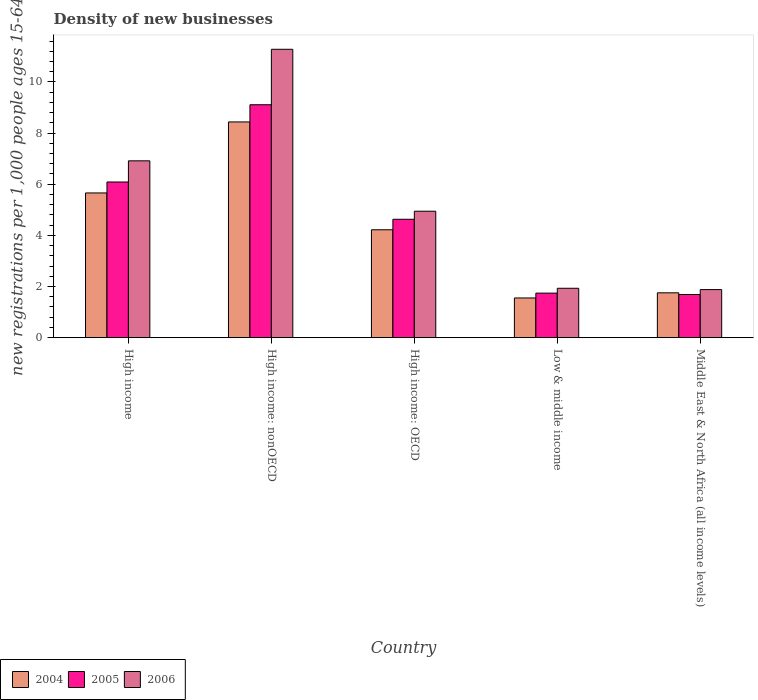Are the number of bars per tick equal to the number of legend labels?
Provide a short and direct response. Yes. How many bars are there on the 4th tick from the left?
Your answer should be very brief. 3. In how many cases, is the number of bars for a given country not equal to the number of legend labels?
Offer a very short reply. 0. What is the number of new registrations in 2004 in Low & middle income?
Offer a terse response. 1.55. Across all countries, what is the maximum number of new registrations in 2004?
Your answer should be compact. 8.44. Across all countries, what is the minimum number of new registrations in 2005?
Your answer should be compact. 1.69. In which country was the number of new registrations in 2004 maximum?
Keep it short and to the point. High income: nonOECD. In which country was the number of new registrations in 2006 minimum?
Keep it short and to the point. Middle East & North Africa (all income levels). What is the total number of new registrations in 2006 in the graph?
Offer a terse response. 26.95. What is the difference between the number of new registrations in 2004 in High income and that in High income: nonOECD?
Provide a short and direct response. -2.78. What is the difference between the number of new registrations in 2005 in High income and the number of new registrations in 2006 in Middle East & North Africa (all income levels)?
Your response must be concise. 4.21. What is the average number of new registrations in 2006 per country?
Your answer should be very brief. 5.39. What is the difference between the number of new registrations of/in 2006 and number of new registrations of/in 2005 in Middle East & North Africa (all income levels)?
Your answer should be compact. 0.19. In how many countries, is the number of new registrations in 2006 greater than 1.2000000000000002?
Give a very brief answer. 5. What is the ratio of the number of new registrations in 2004 in Low & middle income to that in Middle East & North Africa (all income levels)?
Your answer should be very brief. 0.89. Is the difference between the number of new registrations in 2006 in High income: OECD and High income: nonOECD greater than the difference between the number of new registrations in 2005 in High income: OECD and High income: nonOECD?
Your answer should be very brief. No. What is the difference between the highest and the second highest number of new registrations in 2005?
Your response must be concise. 4.48. What is the difference between the highest and the lowest number of new registrations in 2005?
Your answer should be compact. 7.42. In how many countries, is the number of new registrations in 2006 greater than the average number of new registrations in 2006 taken over all countries?
Ensure brevity in your answer.  2. Is the sum of the number of new registrations in 2006 in High income: OECD and Middle East & North Africa (all income levels) greater than the maximum number of new registrations in 2005 across all countries?
Provide a short and direct response. No. What does the 3rd bar from the left in High income represents?
Provide a short and direct response. 2006. What does the 2nd bar from the right in High income represents?
Your answer should be compact. 2005. Is it the case that in every country, the sum of the number of new registrations in 2006 and number of new registrations in 2004 is greater than the number of new registrations in 2005?
Give a very brief answer. Yes. How many bars are there?
Keep it short and to the point. 15. Are all the bars in the graph horizontal?
Offer a very short reply. No. How many countries are there in the graph?
Provide a short and direct response. 5. What is the difference between two consecutive major ticks on the Y-axis?
Your answer should be very brief. 2. Are the values on the major ticks of Y-axis written in scientific E-notation?
Give a very brief answer. No. Does the graph contain grids?
Provide a succinct answer. No. Where does the legend appear in the graph?
Your answer should be compact. Bottom left. What is the title of the graph?
Ensure brevity in your answer.  Density of new businesses. Does "1966" appear as one of the legend labels in the graph?
Your answer should be very brief. No. What is the label or title of the Y-axis?
Keep it short and to the point. New registrations per 1,0 people ages 15-64. What is the new registrations per 1,000 people ages 15-64 of 2004 in High income?
Ensure brevity in your answer.  5.66. What is the new registrations per 1,000 people ages 15-64 in 2005 in High income?
Ensure brevity in your answer.  6.09. What is the new registrations per 1,000 people ages 15-64 in 2006 in High income?
Provide a short and direct response. 6.91. What is the new registrations per 1,000 people ages 15-64 in 2004 in High income: nonOECD?
Your response must be concise. 8.44. What is the new registrations per 1,000 people ages 15-64 in 2005 in High income: nonOECD?
Ensure brevity in your answer.  9.11. What is the new registrations per 1,000 people ages 15-64 in 2006 in High income: nonOECD?
Your response must be concise. 11.28. What is the new registrations per 1,000 people ages 15-64 of 2004 in High income: OECD?
Offer a very short reply. 4.22. What is the new registrations per 1,000 people ages 15-64 in 2005 in High income: OECD?
Provide a short and direct response. 4.63. What is the new registrations per 1,000 people ages 15-64 in 2006 in High income: OECD?
Your response must be concise. 4.94. What is the new registrations per 1,000 people ages 15-64 of 2004 in Low & middle income?
Give a very brief answer. 1.55. What is the new registrations per 1,000 people ages 15-64 of 2005 in Low & middle income?
Give a very brief answer. 1.74. What is the new registrations per 1,000 people ages 15-64 in 2006 in Low & middle income?
Give a very brief answer. 1.93. What is the new registrations per 1,000 people ages 15-64 of 2004 in Middle East & North Africa (all income levels)?
Make the answer very short. 1.75. What is the new registrations per 1,000 people ages 15-64 in 2005 in Middle East & North Africa (all income levels)?
Offer a terse response. 1.69. What is the new registrations per 1,000 people ages 15-64 in 2006 in Middle East & North Africa (all income levels)?
Give a very brief answer. 1.88. Across all countries, what is the maximum new registrations per 1,000 people ages 15-64 in 2004?
Make the answer very short. 8.44. Across all countries, what is the maximum new registrations per 1,000 people ages 15-64 in 2005?
Your answer should be very brief. 9.11. Across all countries, what is the maximum new registrations per 1,000 people ages 15-64 in 2006?
Provide a short and direct response. 11.28. Across all countries, what is the minimum new registrations per 1,000 people ages 15-64 of 2004?
Your answer should be compact. 1.55. Across all countries, what is the minimum new registrations per 1,000 people ages 15-64 in 2005?
Your answer should be very brief. 1.69. Across all countries, what is the minimum new registrations per 1,000 people ages 15-64 in 2006?
Keep it short and to the point. 1.88. What is the total new registrations per 1,000 people ages 15-64 in 2004 in the graph?
Give a very brief answer. 21.62. What is the total new registrations per 1,000 people ages 15-64 in 2005 in the graph?
Provide a succinct answer. 23.25. What is the total new registrations per 1,000 people ages 15-64 in 2006 in the graph?
Ensure brevity in your answer.  26.95. What is the difference between the new registrations per 1,000 people ages 15-64 of 2004 in High income and that in High income: nonOECD?
Give a very brief answer. -2.78. What is the difference between the new registrations per 1,000 people ages 15-64 of 2005 in High income and that in High income: nonOECD?
Provide a short and direct response. -3.02. What is the difference between the new registrations per 1,000 people ages 15-64 in 2006 in High income and that in High income: nonOECD?
Ensure brevity in your answer.  -4.36. What is the difference between the new registrations per 1,000 people ages 15-64 of 2004 in High income and that in High income: OECD?
Ensure brevity in your answer.  1.44. What is the difference between the new registrations per 1,000 people ages 15-64 of 2005 in High income and that in High income: OECD?
Your answer should be compact. 1.46. What is the difference between the new registrations per 1,000 people ages 15-64 of 2006 in High income and that in High income: OECD?
Keep it short and to the point. 1.97. What is the difference between the new registrations per 1,000 people ages 15-64 of 2004 in High income and that in Low & middle income?
Your answer should be very brief. 4.11. What is the difference between the new registrations per 1,000 people ages 15-64 of 2005 in High income and that in Low & middle income?
Your answer should be compact. 4.35. What is the difference between the new registrations per 1,000 people ages 15-64 in 2006 in High income and that in Low & middle income?
Offer a very short reply. 4.98. What is the difference between the new registrations per 1,000 people ages 15-64 in 2004 in High income and that in Middle East & North Africa (all income levels)?
Offer a very short reply. 3.91. What is the difference between the new registrations per 1,000 people ages 15-64 in 2005 in High income and that in Middle East & North Africa (all income levels)?
Ensure brevity in your answer.  4.4. What is the difference between the new registrations per 1,000 people ages 15-64 in 2006 in High income and that in Middle East & North Africa (all income levels)?
Provide a succinct answer. 5.04. What is the difference between the new registrations per 1,000 people ages 15-64 in 2004 in High income: nonOECD and that in High income: OECD?
Ensure brevity in your answer.  4.22. What is the difference between the new registrations per 1,000 people ages 15-64 in 2005 in High income: nonOECD and that in High income: OECD?
Your answer should be very brief. 4.48. What is the difference between the new registrations per 1,000 people ages 15-64 in 2006 in High income: nonOECD and that in High income: OECD?
Ensure brevity in your answer.  6.33. What is the difference between the new registrations per 1,000 people ages 15-64 in 2004 in High income: nonOECD and that in Low & middle income?
Your response must be concise. 6.88. What is the difference between the new registrations per 1,000 people ages 15-64 of 2005 in High income: nonOECD and that in Low & middle income?
Offer a terse response. 7.37. What is the difference between the new registrations per 1,000 people ages 15-64 in 2006 in High income: nonOECD and that in Low & middle income?
Give a very brief answer. 9.34. What is the difference between the new registrations per 1,000 people ages 15-64 of 2004 in High income: nonOECD and that in Middle East & North Africa (all income levels)?
Your answer should be compact. 6.68. What is the difference between the new registrations per 1,000 people ages 15-64 of 2005 in High income: nonOECD and that in Middle East & North Africa (all income levels)?
Your response must be concise. 7.42. What is the difference between the new registrations per 1,000 people ages 15-64 of 2006 in High income: nonOECD and that in Middle East & North Africa (all income levels)?
Offer a very short reply. 9.4. What is the difference between the new registrations per 1,000 people ages 15-64 in 2004 in High income: OECD and that in Low & middle income?
Offer a very short reply. 2.67. What is the difference between the new registrations per 1,000 people ages 15-64 of 2005 in High income: OECD and that in Low & middle income?
Provide a short and direct response. 2.89. What is the difference between the new registrations per 1,000 people ages 15-64 in 2006 in High income: OECD and that in Low & middle income?
Ensure brevity in your answer.  3.01. What is the difference between the new registrations per 1,000 people ages 15-64 in 2004 in High income: OECD and that in Middle East & North Africa (all income levels)?
Your response must be concise. 2.47. What is the difference between the new registrations per 1,000 people ages 15-64 of 2005 in High income: OECD and that in Middle East & North Africa (all income levels)?
Make the answer very short. 2.94. What is the difference between the new registrations per 1,000 people ages 15-64 of 2006 in High income: OECD and that in Middle East & North Africa (all income levels)?
Make the answer very short. 3.07. What is the difference between the new registrations per 1,000 people ages 15-64 of 2004 in Low & middle income and that in Middle East & North Africa (all income levels)?
Keep it short and to the point. -0.2. What is the difference between the new registrations per 1,000 people ages 15-64 of 2005 in Low & middle income and that in Middle East & North Africa (all income levels)?
Give a very brief answer. 0.05. What is the difference between the new registrations per 1,000 people ages 15-64 in 2006 in Low & middle income and that in Middle East & North Africa (all income levels)?
Your answer should be very brief. 0.05. What is the difference between the new registrations per 1,000 people ages 15-64 of 2004 in High income and the new registrations per 1,000 people ages 15-64 of 2005 in High income: nonOECD?
Ensure brevity in your answer.  -3.45. What is the difference between the new registrations per 1,000 people ages 15-64 in 2004 in High income and the new registrations per 1,000 people ages 15-64 in 2006 in High income: nonOECD?
Make the answer very short. -5.62. What is the difference between the new registrations per 1,000 people ages 15-64 in 2005 in High income and the new registrations per 1,000 people ages 15-64 in 2006 in High income: nonOECD?
Your answer should be compact. -5.19. What is the difference between the new registrations per 1,000 people ages 15-64 of 2004 in High income and the new registrations per 1,000 people ages 15-64 of 2005 in High income: OECD?
Your response must be concise. 1.03. What is the difference between the new registrations per 1,000 people ages 15-64 in 2004 in High income and the new registrations per 1,000 people ages 15-64 in 2006 in High income: OECD?
Keep it short and to the point. 0.71. What is the difference between the new registrations per 1,000 people ages 15-64 in 2005 in High income and the new registrations per 1,000 people ages 15-64 in 2006 in High income: OECD?
Give a very brief answer. 1.14. What is the difference between the new registrations per 1,000 people ages 15-64 in 2004 in High income and the new registrations per 1,000 people ages 15-64 in 2005 in Low & middle income?
Provide a succinct answer. 3.92. What is the difference between the new registrations per 1,000 people ages 15-64 in 2004 in High income and the new registrations per 1,000 people ages 15-64 in 2006 in Low & middle income?
Your answer should be compact. 3.73. What is the difference between the new registrations per 1,000 people ages 15-64 in 2005 in High income and the new registrations per 1,000 people ages 15-64 in 2006 in Low & middle income?
Your answer should be very brief. 4.16. What is the difference between the new registrations per 1,000 people ages 15-64 in 2004 in High income and the new registrations per 1,000 people ages 15-64 in 2005 in Middle East & North Africa (all income levels)?
Your answer should be very brief. 3.97. What is the difference between the new registrations per 1,000 people ages 15-64 of 2004 in High income and the new registrations per 1,000 people ages 15-64 of 2006 in Middle East & North Africa (all income levels)?
Ensure brevity in your answer.  3.78. What is the difference between the new registrations per 1,000 people ages 15-64 in 2005 in High income and the new registrations per 1,000 people ages 15-64 in 2006 in Middle East & North Africa (all income levels)?
Offer a terse response. 4.21. What is the difference between the new registrations per 1,000 people ages 15-64 in 2004 in High income: nonOECD and the new registrations per 1,000 people ages 15-64 in 2005 in High income: OECD?
Your response must be concise. 3.81. What is the difference between the new registrations per 1,000 people ages 15-64 in 2004 in High income: nonOECD and the new registrations per 1,000 people ages 15-64 in 2006 in High income: OECD?
Your answer should be compact. 3.49. What is the difference between the new registrations per 1,000 people ages 15-64 in 2005 in High income: nonOECD and the new registrations per 1,000 people ages 15-64 in 2006 in High income: OECD?
Offer a terse response. 4.16. What is the difference between the new registrations per 1,000 people ages 15-64 in 2004 in High income: nonOECD and the new registrations per 1,000 people ages 15-64 in 2005 in Low & middle income?
Ensure brevity in your answer.  6.69. What is the difference between the new registrations per 1,000 people ages 15-64 of 2004 in High income: nonOECD and the new registrations per 1,000 people ages 15-64 of 2006 in Low & middle income?
Ensure brevity in your answer.  6.5. What is the difference between the new registrations per 1,000 people ages 15-64 of 2005 in High income: nonOECD and the new registrations per 1,000 people ages 15-64 of 2006 in Low & middle income?
Ensure brevity in your answer.  7.18. What is the difference between the new registrations per 1,000 people ages 15-64 in 2004 in High income: nonOECD and the new registrations per 1,000 people ages 15-64 in 2005 in Middle East & North Africa (all income levels)?
Offer a very short reply. 6.75. What is the difference between the new registrations per 1,000 people ages 15-64 in 2004 in High income: nonOECD and the new registrations per 1,000 people ages 15-64 in 2006 in Middle East & North Africa (all income levels)?
Give a very brief answer. 6.56. What is the difference between the new registrations per 1,000 people ages 15-64 of 2005 in High income: nonOECD and the new registrations per 1,000 people ages 15-64 of 2006 in Middle East & North Africa (all income levels)?
Your answer should be very brief. 7.23. What is the difference between the new registrations per 1,000 people ages 15-64 of 2004 in High income: OECD and the new registrations per 1,000 people ages 15-64 of 2005 in Low & middle income?
Offer a terse response. 2.48. What is the difference between the new registrations per 1,000 people ages 15-64 in 2004 in High income: OECD and the new registrations per 1,000 people ages 15-64 in 2006 in Low & middle income?
Keep it short and to the point. 2.29. What is the difference between the new registrations per 1,000 people ages 15-64 in 2005 in High income: OECD and the new registrations per 1,000 people ages 15-64 in 2006 in Low & middle income?
Offer a very short reply. 2.7. What is the difference between the new registrations per 1,000 people ages 15-64 of 2004 in High income: OECD and the new registrations per 1,000 people ages 15-64 of 2005 in Middle East & North Africa (all income levels)?
Make the answer very short. 2.53. What is the difference between the new registrations per 1,000 people ages 15-64 in 2004 in High income: OECD and the new registrations per 1,000 people ages 15-64 in 2006 in Middle East & North Africa (all income levels)?
Provide a short and direct response. 2.34. What is the difference between the new registrations per 1,000 people ages 15-64 of 2005 in High income: OECD and the new registrations per 1,000 people ages 15-64 of 2006 in Middle East & North Africa (all income levels)?
Ensure brevity in your answer.  2.75. What is the difference between the new registrations per 1,000 people ages 15-64 in 2004 in Low & middle income and the new registrations per 1,000 people ages 15-64 in 2005 in Middle East & North Africa (all income levels)?
Make the answer very short. -0.13. What is the difference between the new registrations per 1,000 people ages 15-64 in 2004 in Low & middle income and the new registrations per 1,000 people ages 15-64 in 2006 in Middle East & North Africa (all income levels)?
Your answer should be very brief. -0.33. What is the difference between the new registrations per 1,000 people ages 15-64 of 2005 in Low & middle income and the new registrations per 1,000 people ages 15-64 of 2006 in Middle East & North Africa (all income levels)?
Provide a short and direct response. -0.14. What is the average new registrations per 1,000 people ages 15-64 in 2004 per country?
Provide a short and direct response. 4.32. What is the average new registrations per 1,000 people ages 15-64 in 2005 per country?
Your answer should be compact. 4.65. What is the average new registrations per 1,000 people ages 15-64 in 2006 per country?
Keep it short and to the point. 5.39. What is the difference between the new registrations per 1,000 people ages 15-64 in 2004 and new registrations per 1,000 people ages 15-64 in 2005 in High income?
Make the answer very short. -0.43. What is the difference between the new registrations per 1,000 people ages 15-64 in 2004 and new registrations per 1,000 people ages 15-64 in 2006 in High income?
Ensure brevity in your answer.  -1.26. What is the difference between the new registrations per 1,000 people ages 15-64 of 2005 and new registrations per 1,000 people ages 15-64 of 2006 in High income?
Provide a succinct answer. -0.83. What is the difference between the new registrations per 1,000 people ages 15-64 of 2004 and new registrations per 1,000 people ages 15-64 of 2005 in High income: nonOECD?
Your response must be concise. -0.67. What is the difference between the new registrations per 1,000 people ages 15-64 in 2004 and new registrations per 1,000 people ages 15-64 in 2006 in High income: nonOECD?
Keep it short and to the point. -2.84. What is the difference between the new registrations per 1,000 people ages 15-64 of 2005 and new registrations per 1,000 people ages 15-64 of 2006 in High income: nonOECD?
Your answer should be compact. -2.17. What is the difference between the new registrations per 1,000 people ages 15-64 of 2004 and new registrations per 1,000 people ages 15-64 of 2005 in High income: OECD?
Offer a very short reply. -0.41. What is the difference between the new registrations per 1,000 people ages 15-64 in 2004 and new registrations per 1,000 people ages 15-64 in 2006 in High income: OECD?
Offer a very short reply. -0.73. What is the difference between the new registrations per 1,000 people ages 15-64 of 2005 and new registrations per 1,000 people ages 15-64 of 2006 in High income: OECD?
Give a very brief answer. -0.32. What is the difference between the new registrations per 1,000 people ages 15-64 in 2004 and new registrations per 1,000 people ages 15-64 in 2005 in Low & middle income?
Make the answer very short. -0.19. What is the difference between the new registrations per 1,000 people ages 15-64 in 2004 and new registrations per 1,000 people ages 15-64 in 2006 in Low & middle income?
Give a very brief answer. -0.38. What is the difference between the new registrations per 1,000 people ages 15-64 of 2005 and new registrations per 1,000 people ages 15-64 of 2006 in Low & middle income?
Ensure brevity in your answer.  -0.19. What is the difference between the new registrations per 1,000 people ages 15-64 of 2004 and new registrations per 1,000 people ages 15-64 of 2005 in Middle East & North Africa (all income levels)?
Give a very brief answer. 0.07. What is the difference between the new registrations per 1,000 people ages 15-64 of 2004 and new registrations per 1,000 people ages 15-64 of 2006 in Middle East & North Africa (all income levels)?
Ensure brevity in your answer.  -0.13. What is the difference between the new registrations per 1,000 people ages 15-64 in 2005 and new registrations per 1,000 people ages 15-64 in 2006 in Middle East & North Africa (all income levels)?
Keep it short and to the point. -0.19. What is the ratio of the new registrations per 1,000 people ages 15-64 of 2004 in High income to that in High income: nonOECD?
Your answer should be very brief. 0.67. What is the ratio of the new registrations per 1,000 people ages 15-64 of 2005 in High income to that in High income: nonOECD?
Make the answer very short. 0.67. What is the ratio of the new registrations per 1,000 people ages 15-64 in 2006 in High income to that in High income: nonOECD?
Offer a terse response. 0.61. What is the ratio of the new registrations per 1,000 people ages 15-64 in 2004 in High income to that in High income: OECD?
Keep it short and to the point. 1.34. What is the ratio of the new registrations per 1,000 people ages 15-64 in 2005 in High income to that in High income: OECD?
Keep it short and to the point. 1.31. What is the ratio of the new registrations per 1,000 people ages 15-64 of 2006 in High income to that in High income: OECD?
Your answer should be compact. 1.4. What is the ratio of the new registrations per 1,000 people ages 15-64 of 2004 in High income to that in Low & middle income?
Offer a very short reply. 3.64. What is the ratio of the new registrations per 1,000 people ages 15-64 in 2005 in High income to that in Low & middle income?
Provide a succinct answer. 3.5. What is the ratio of the new registrations per 1,000 people ages 15-64 of 2006 in High income to that in Low & middle income?
Your answer should be compact. 3.58. What is the ratio of the new registrations per 1,000 people ages 15-64 in 2004 in High income to that in Middle East & North Africa (all income levels)?
Offer a terse response. 3.23. What is the ratio of the new registrations per 1,000 people ages 15-64 of 2005 in High income to that in Middle East & North Africa (all income levels)?
Your response must be concise. 3.61. What is the ratio of the new registrations per 1,000 people ages 15-64 in 2006 in High income to that in Middle East & North Africa (all income levels)?
Ensure brevity in your answer.  3.68. What is the ratio of the new registrations per 1,000 people ages 15-64 in 2004 in High income: nonOECD to that in High income: OECD?
Provide a succinct answer. 2. What is the ratio of the new registrations per 1,000 people ages 15-64 of 2005 in High income: nonOECD to that in High income: OECD?
Offer a terse response. 1.97. What is the ratio of the new registrations per 1,000 people ages 15-64 in 2006 in High income: nonOECD to that in High income: OECD?
Give a very brief answer. 2.28. What is the ratio of the new registrations per 1,000 people ages 15-64 in 2004 in High income: nonOECD to that in Low & middle income?
Provide a succinct answer. 5.43. What is the ratio of the new registrations per 1,000 people ages 15-64 in 2005 in High income: nonOECD to that in Low & middle income?
Offer a very short reply. 5.23. What is the ratio of the new registrations per 1,000 people ages 15-64 in 2006 in High income: nonOECD to that in Low & middle income?
Offer a very short reply. 5.84. What is the ratio of the new registrations per 1,000 people ages 15-64 of 2004 in High income: nonOECD to that in Middle East & North Africa (all income levels)?
Your answer should be compact. 4.81. What is the ratio of the new registrations per 1,000 people ages 15-64 in 2005 in High income: nonOECD to that in Middle East & North Africa (all income levels)?
Make the answer very short. 5.4. What is the ratio of the new registrations per 1,000 people ages 15-64 in 2006 in High income: nonOECD to that in Middle East & North Africa (all income levels)?
Keep it short and to the point. 6. What is the ratio of the new registrations per 1,000 people ages 15-64 of 2004 in High income: OECD to that in Low & middle income?
Offer a terse response. 2.72. What is the ratio of the new registrations per 1,000 people ages 15-64 of 2005 in High income: OECD to that in Low & middle income?
Ensure brevity in your answer.  2.66. What is the ratio of the new registrations per 1,000 people ages 15-64 in 2006 in High income: OECD to that in Low & middle income?
Your answer should be compact. 2.56. What is the ratio of the new registrations per 1,000 people ages 15-64 of 2004 in High income: OECD to that in Middle East & North Africa (all income levels)?
Your answer should be very brief. 2.41. What is the ratio of the new registrations per 1,000 people ages 15-64 of 2005 in High income: OECD to that in Middle East & North Africa (all income levels)?
Keep it short and to the point. 2.74. What is the ratio of the new registrations per 1,000 people ages 15-64 of 2006 in High income: OECD to that in Middle East & North Africa (all income levels)?
Ensure brevity in your answer.  2.63. What is the ratio of the new registrations per 1,000 people ages 15-64 in 2004 in Low & middle income to that in Middle East & North Africa (all income levels)?
Provide a succinct answer. 0.89. What is the ratio of the new registrations per 1,000 people ages 15-64 in 2005 in Low & middle income to that in Middle East & North Africa (all income levels)?
Your response must be concise. 1.03. What is the ratio of the new registrations per 1,000 people ages 15-64 of 2006 in Low & middle income to that in Middle East & North Africa (all income levels)?
Your answer should be very brief. 1.03. What is the difference between the highest and the second highest new registrations per 1,000 people ages 15-64 in 2004?
Ensure brevity in your answer.  2.78. What is the difference between the highest and the second highest new registrations per 1,000 people ages 15-64 in 2005?
Give a very brief answer. 3.02. What is the difference between the highest and the second highest new registrations per 1,000 people ages 15-64 of 2006?
Provide a succinct answer. 4.36. What is the difference between the highest and the lowest new registrations per 1,000 people ages 15-64 in 2004?
Your response must be concise. 6.88. What is the difference between the highest and the lowest new registrations per 1,000 people ages 15-64 in 2005?
Provide a short and direct response. 7.42. What is the difference between the highest and the lowest new registrations per 1,000 people ages 15-64 in 2006?
Give a very brief answer. 9.4. 